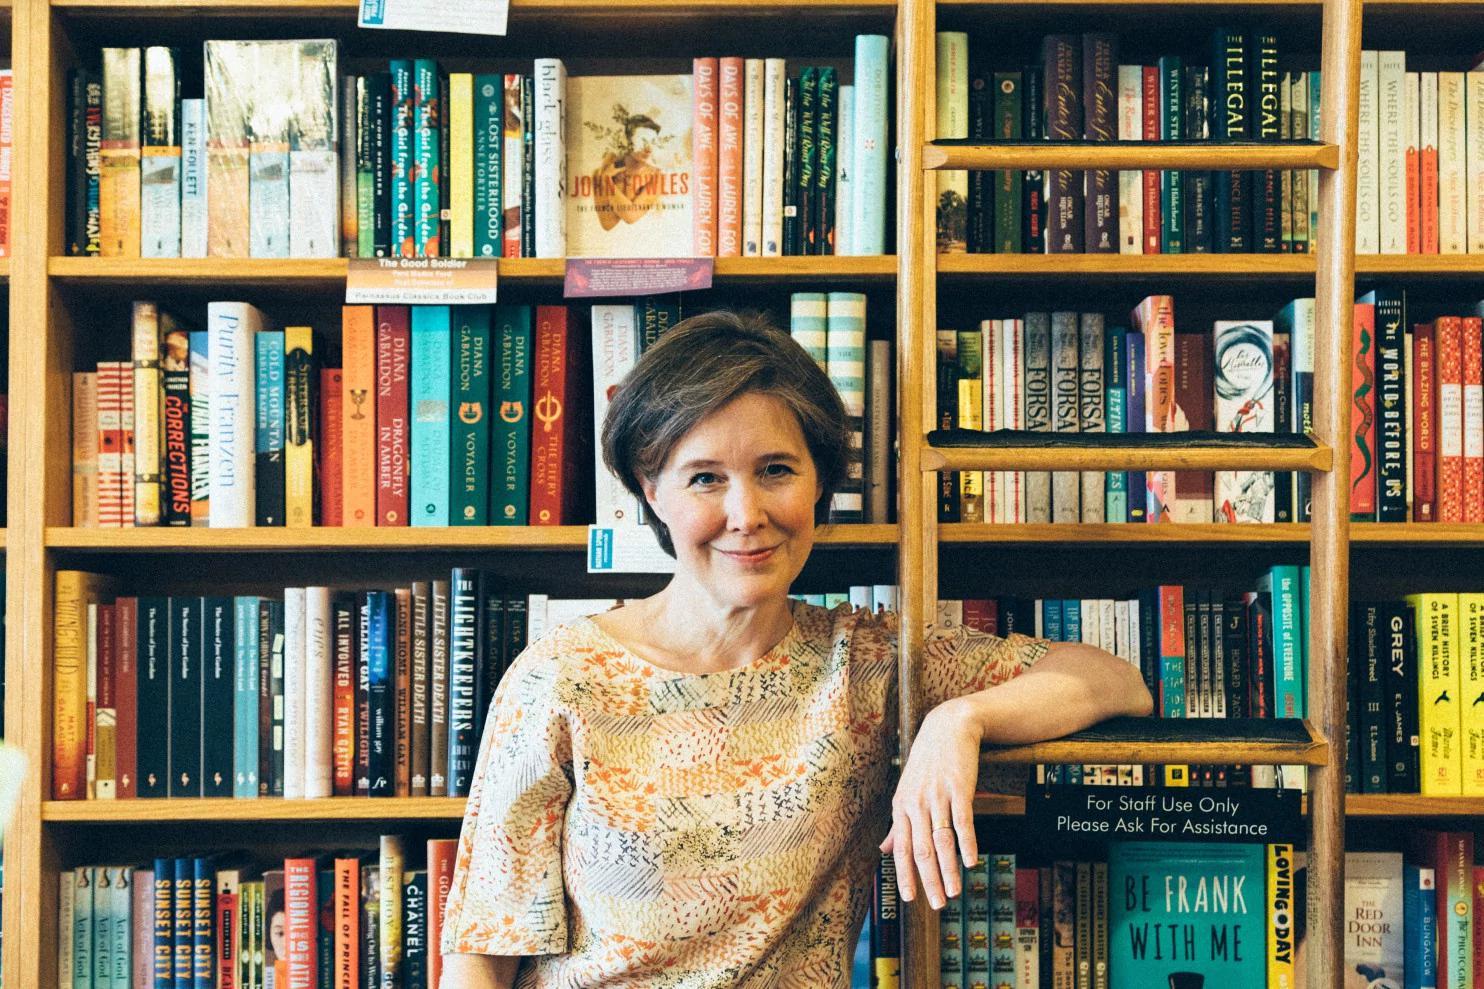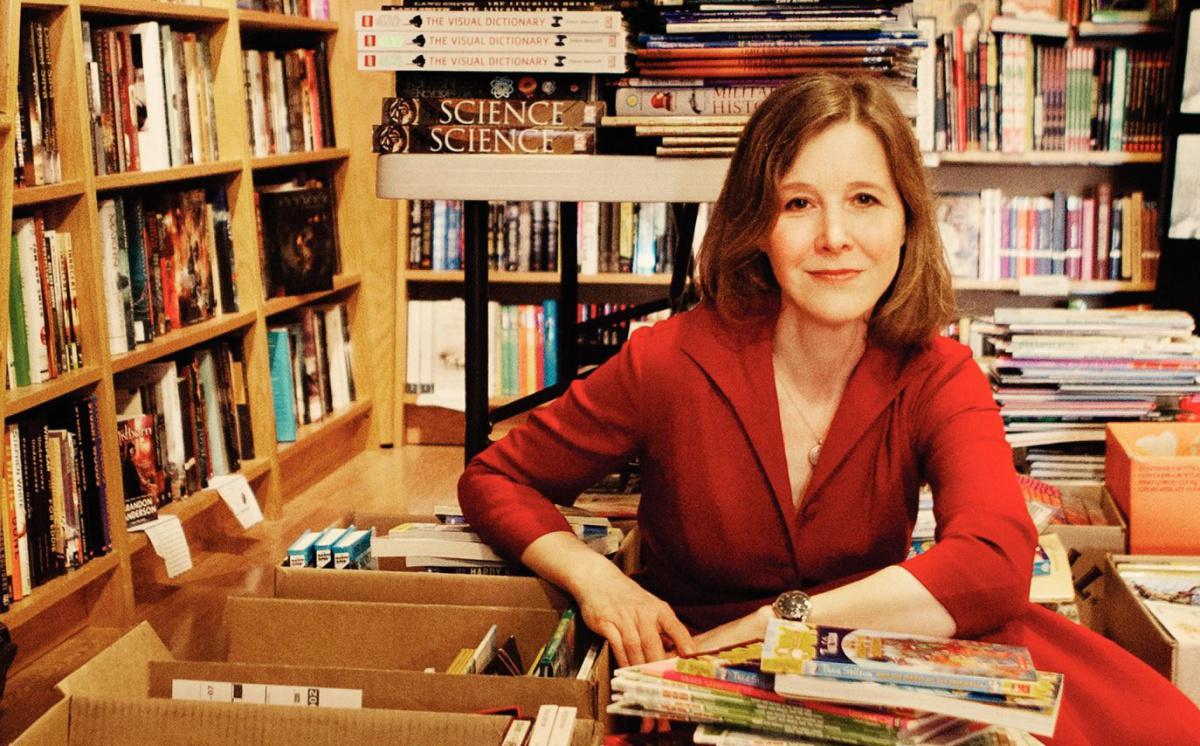The first image is the image on the left, the second image is the image on the right. Examine the images to the left and right. Is the description "One image shows a red-headed woman in a reddish dress sitting in front of open boxes of books." accurate? Answer yes or no. Yes. The first image is the image on the left, the second image is the image on the right. Analyze the images presented: Is the assertion "A woman in a red blouse is sitting at a table of books in one of the images." valid? Answer yes or no. Yes. 